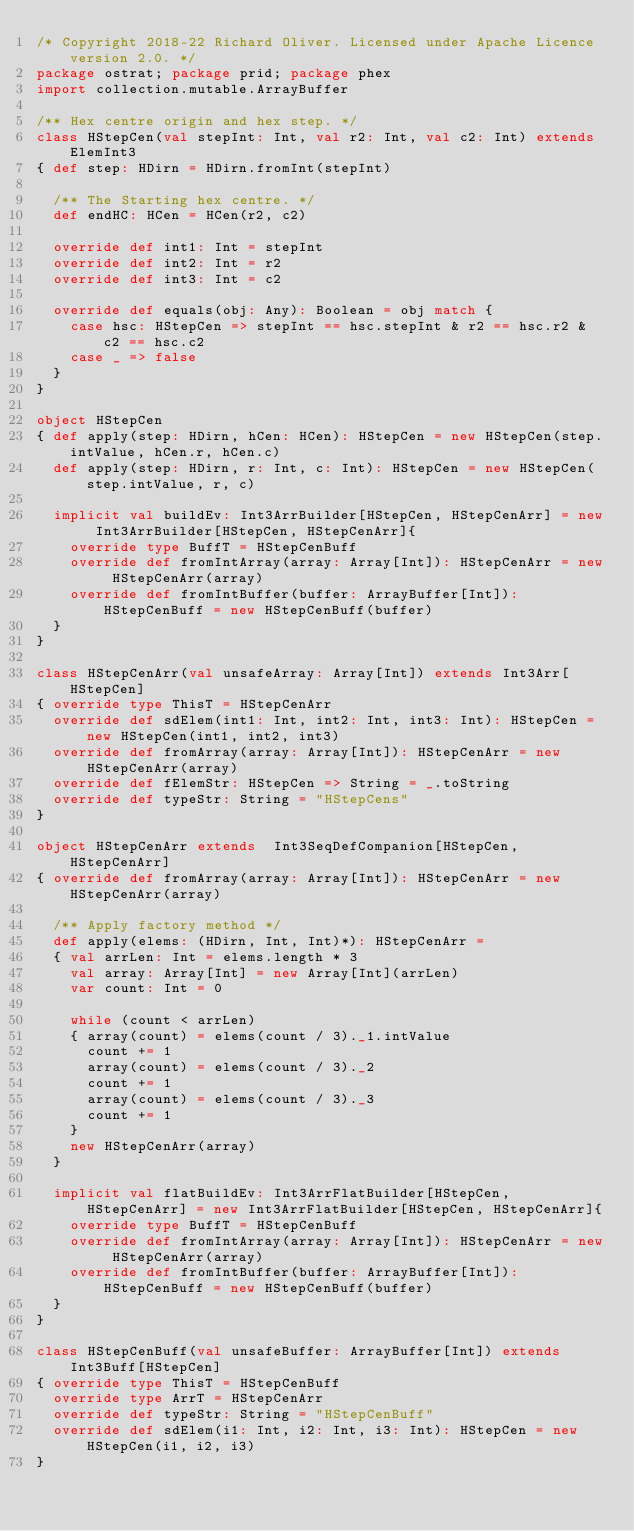<code> <loc_0><loc_0><loc_500><loc_500><_Scala_>/* Copyright 2018-22 Richard Oliver. Licensed under Apache Licence version 2.0. */
package ostrat; package prid; package phex
import collection.mutable.ArrayBuffer

/** Hex centre origin and hex step. */
class HStepCen(val stepInt: Int, val r2: Int, val c2: Int) extends ElemInt3
{ def step: HDirn = HDirn.fromInt(stepInt)

  /** The Starting hex centre. */
  def endHC: HCen = HCen(r2, c2)

  override def int1: Int = stepInt
  override def int2: Int = r2
  override def int3: Int = c2

  override def equals(obj: Any): Boolean = obj match {
    case hsc: HStepCen => stepInt == hsc.stepInt & r2 == hsc.r2 & c2 == hsc.c2
    case _ => false
  }
}

object HStepCen
{ def apply(step: HDirn, hCen: HCen): HStepCen = new HStepCen(step.intValue, hCen.r, hCen.c)
  def apply(step: HDirn, r: Int, c: Int): HStepCen = new HStepCen(step.intValue, r, c)

  implicit val buildEv: Int3ArrBuilder[HStepCen, HStepCenArr] = new Int3ArrBuilder[HStepCen, HStepCenArr]{
    override type BuffT = HStepCenBuff
    override def fromIntArray(array: Array[Int]): HStepCenArr = new HStepCenArr(array)
    override def fromIntBuffer(buffer: ArrayBuffer[Int]): HStepCenBuff = new HStepCenBuff(buffer)
  }
}

class HStepCenArr(val unsafeArray: Array[Int]) extends Int3Arr[HStepCen]
{ override type ThisT = HStepCenArr
  override def sdElem(int1: Int, int2: Int, int3: Int): HStepCen = new HStepCen(int1, int2, int3)
  override def fromArray(array: Array[Int]): HStepCenArr = new HStepCenArr(array)
  override def fElemStr: HStepCen => String = _.toString
  override def typeStr: String = "HStepCens"
}

object HStepCenArr extends  Int3SeqDefCompanion[HStepCen, HStepCenArr]
{ override def fromArray(array: Array[Int]): HStepCenArr = new HStepCenArr(array)

  /** Apply factory method */
  def apply(elems: (HDirn, Int, Int)*): HStepCenArr =
  { val arrLen: Int = elems.length * 3
    val array: Array[Int] = new Array[Int](arrLen)
    var count: Int = 0

    while (count < arrLen)
    { array(count) = elems(count / 3)._1.intValue
      count += 1
      array(count) = elems(count / 3)._2
      count += 1
      array(count) = elems(count / 3)._3
      count += 1
    }
    new HStepCenArr(array)
  }

  implicit val flatBuildEv: Int3ArrFlatBuilder[HStepCen, HStepCenArr] = new Int3ArrFlatBuilder[HStepCen, HStepCenArr]{
    override type BuffT = HStepCenBuff
    override def fromIntArray(array: Array[Int]): HStepCenArr = new HStepCenArr(array)
    override def fromIntBuffer(buffer: ArrayBuffer[Int]): HStepCenBuff = new HStepCenBuff(buffer)
  }
}

class HStepCenBuff(val unsafeBuffer: ArrayBuffer[Int]) extends Int3Buff[HStepCen]
{ override type ThisT = HStepCenBuff
  override type ArrT = HStepCenArr
  override def typeStr: String = "HStepCenBuff"
  override def sdElem(i1: Int, i2: Int, i3: Int): HStepCen = new HStepCen(i1, i2, i3)
}</code> 